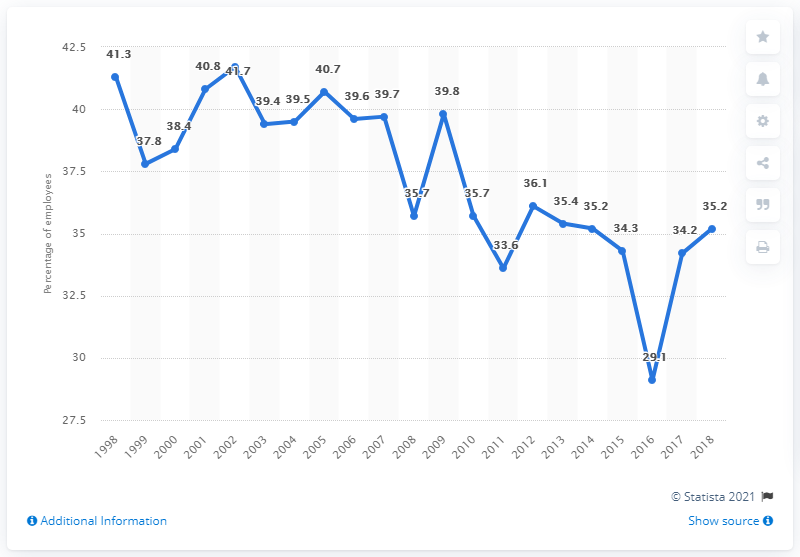Point out several critical features in this image. In 2018, 35.2% of employees were members of a trade union. 